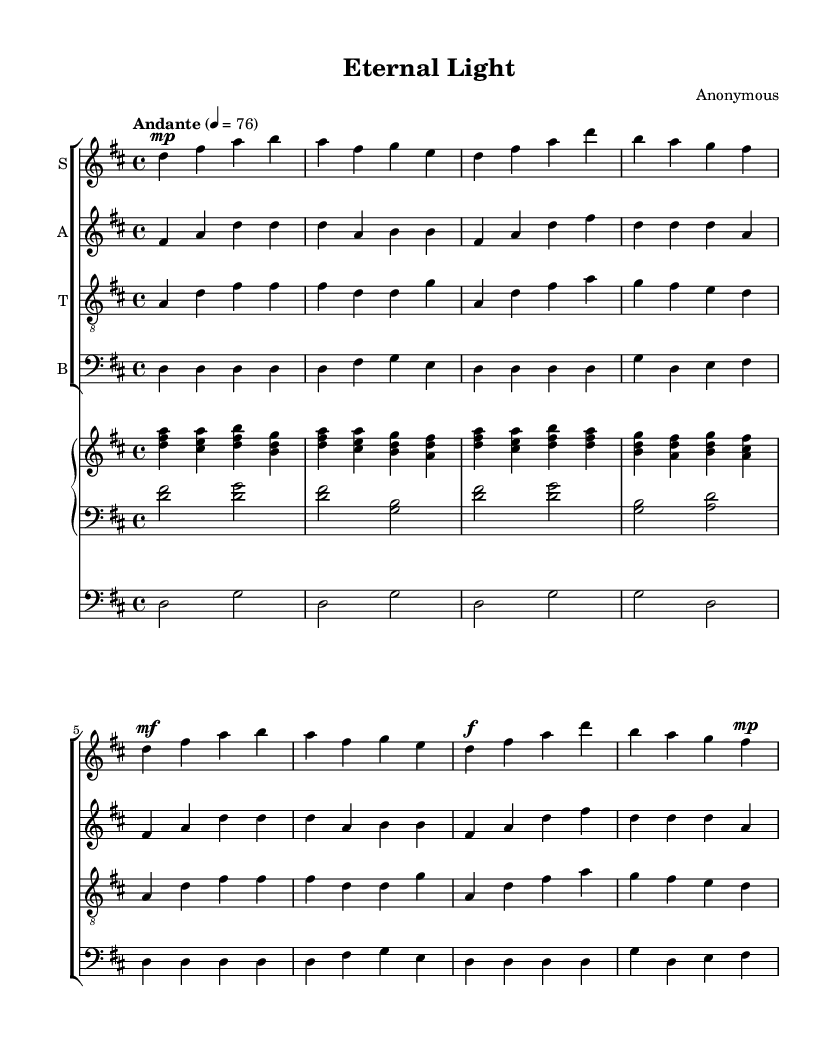What is the key signature of this music? The key signature appears at the beginning of the staff system; it consists of two sharps, indicating it is in the key of D major.
Answer: D major What is the time signature of this piece? The time signature is indicated after the key signature; it shows a "4/4" symbol, meaning there are four beats in each measure.
Answer: 4/4 What is the tempo marking for this music? The tempo marking is found above the first measure, indicating "Andante" with a metronome marking of 76, which suggests a moderately slow pace for the piece.
Answer: Andante, 76 How many voices are present in the choral arrangement? By examining the score layout, there are four distinct vocal parts: soprano, alto, tenor, and bass, all represented on separate staves.
Answer: Four What is the function of the pedal line in this composition? The pedal part, located on its own staff, supports the harmony by providing a sustained bass foundation throughout the piece, reinforcing the chords played by the hands.
Answer: Bass foundation In which section of the music do dynamics change to mezzo-forte? Looking at the score, the dynamics change to mezzo-forte (mf) on the 5th measure of the soprano part, where it shifts from piano to a stronger volume.
Answer: 5th measure 